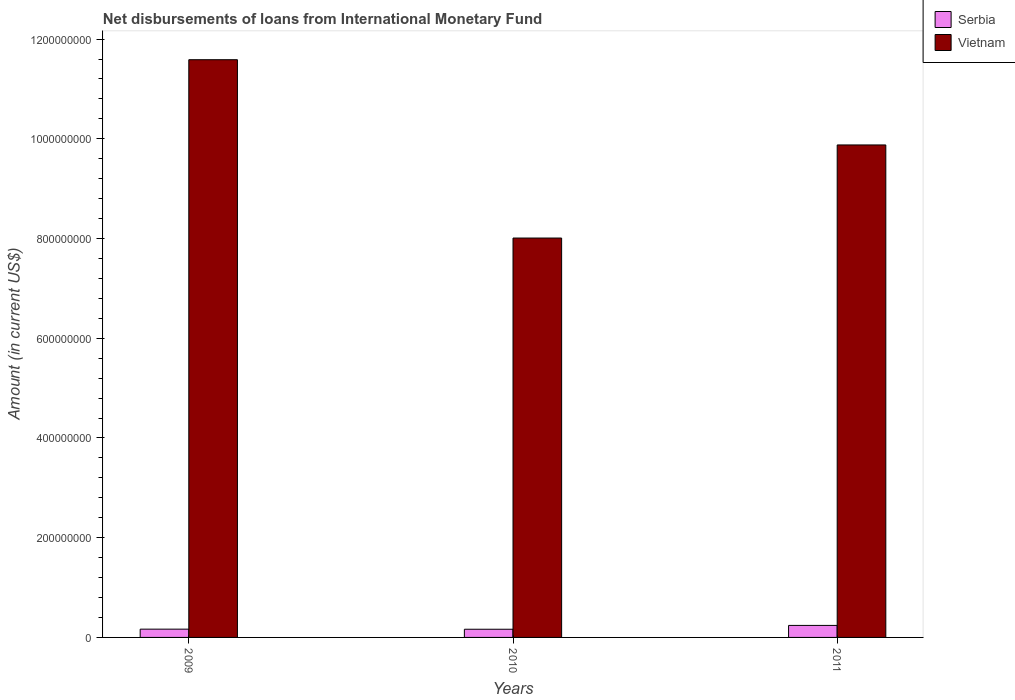How many different coloured bars are there?
Your response must be concise. 2. How many groups of bars are there?
Your response must be concise. 3. Are the number of bars on each tick of the X-axis equal?
Provide a short and direct response. Yes. What is the label of the 2nd group of bars from the left?
Make the answer very short. 2010. In how many cases, is the number of bars for a given year not equal to the number of legend labels?
Give a very brief answer. 0. What is the amount of loans disbursed in Vietnam in 2010?
Your answer should be compact. 8.01e+08. Across all years, what is the maximum amount of loans disbursed in Serbia?
Keep it short and to the point. 2.41e+07. Across all years, what is the minimum amount of loans disbursed in Vietnam?
Keep it short and to the point. 8.01e+08. What is the total amount of loans disbursed in Vietnam in the graph?
Offer a terse response. 2.95e+09. What is the difference between the amount of loans disbursed in Vietnam in 2009 and that in 2011?
Give a very brief answer. 1.71e+08. What is the difference between the amount of loans disbursed in Vietnam in 2011 and the amount of loans disbursed in Serbia in 2009?
Offer a terse response. 9.71e+08. What is the average amount of loans disbursed in Vietnam per year?
Your response must be concise. 9.82e+08. In the year 2009, what is the difference between the amount of loans disbursed in Serbia and amount of loans disbursed in Vietnam?
Your answer should be very brief. -1.14e+09. In how many years, is the amount of loans disbursed in Serbia greater than 1080000000 US$?
Make the answer very short. 0. What is the ratio of the amount of loans disbursed in Vietnam in 2009 to that in 2010?
Give a very brief answer. 1.45. What is the difference between the highest and the second highest amount of loans disbursed in Serbia?
Your answer should be compact. 7.47e+06. What is the difference between the highest and the lowest amount of loans disbursed in Vietnam?
Keep it short and to the point. 3.58e+08. Is the sum of the amount of loans disbursed in Vietnam in 2009 and 2011 greater than the maximum amount of loans disbursed in Serbia across all years?
Keep it short and to the point. Yes. What does the 1st bar from the left in 2011 represents?
Your response must be concise. Serbia. What does the 1st bar from the right in 2011 represents?
Give a very brief answer. Vietnam. Are all the bars in the graph horizontal?
Your answer should be very brief. No. How many years are there in the graph?
Offer a terse response. 3. What is the difference between two consecutive major ticks on the Y-axis?
Provide a short and direct response. 2.00e+08. Where does the legend appear in the graph?
Your response must be concise. Top right. How many legend labels are there?
Give a very brief answer. 2. How are the legend labels stacked?
Ensure brevity in your answer.  Vertical. What is the title of the graph?
Make the answer very short. Net disbursements of loans from International Monetary Fund. What is the Amount (in current US$) of Serbia in 2009?
Provide a succinct answer. 1.66e+07. What is the Amount (in current US$) of Vietnam in 2009?
Provide a short and direct response. 1.16e+09. What is the Amount (in current US$) in Serbia in 2010?
Your response must be concise. 1.64e+07. What is the Amount (in current US$) in Vietnam in 2010?
Make the answer very short. 8.01e+08. What is the Amount (in current US$) of Serbia in 2011?
Your response must be concise. 2.41e+07. What is the Amount (in current US$) in Vietnam in 2011?
Ensure brevity in your answer.  9.88e+08. Across all years, what is the maximum Amount (in current US$) of Serbia?
Make the answer very short. 2.41e+07. Across all years, what is the maximum Amount (in current US$) of Vietnam?
Ensure brevity in your answer.  1.16e+09. Across all years, what is the minimum Amount (in current US$) in Serbia?
Ensure brevity in your answer.  1.64e+07. Across all years, what is the minimum Amount (in current US$) in Vietnam?
Your answer should be compact. 8.01e+08. What is the total Amount (in current US$) of Serbia in the graph?
Your answer should be compact. 5.71e+07. What is the total Amount (in current US$) of Vietnam in the graph?
Your answer should be very brief. 2.95e+09. What is the difference between the Amount (in current US$) of Serbia in 2009 and that in 2010?
Provide a succinct answer. 2.02e+05. What is the difference between the Amount (in current US$) of Vietnam in 2009 and that in 2010?
Your answer should be compact. 3.58e+08. What is the difference between the Amount (in current US$) in Serbia in 2009 and that in 2011?
Your answer should be compact. -7.47e+06. What is the difference between the Amount (in current US$) of Vietnam in 2009 and that in 2011?
Your answer should be very brief. 1.71e+08. What is the difference between the Amount (in current US$) of Serbia in 2010 and that in 2011?
Give a very brief answer. -7.67e+06. What is the difference between the Amount (in current US$) of Vietnam in 2010 and that in 2011?
Offer a terse response. -1.87e+08. What is the difference between the Amount (in current US$) in Serbia in 2009 and the Amount (in current US$) in Vietnam in 2010?
Keep it short and to the point. -7.84e+08. What is the difference between the Amount (in current US$) of Serbia in 2009 and the Amount (in current US$) of Vietnam in 2011?
Offer a very short reply. -9.71e+08. What is the difference between the Amount (in current US$) in Serbia in 2010 and the Amount (in current US$) in Vietnam in 2011?
Your answer should be compact. -9.71e+08. What is the average Amount (in current US$) in Serbia per year?
Provide a short and direct response. 1.90e+07. What is the average Amount (in current US$) of Vietnam per year?
Provide a short and direct response. 9.82e+08. In the year 2009, what is the difference between the Amount (in current US$) in Serbia and Amount (in current US$) in Vietnam?
Your response must be concise. -1.14e+09. In the year 2010, what is the difference between the Amount (in current US$) in Serbia and Amount (in current US$) in Vietnam?
Offer a terse response. -7.85e+08. In the year 2011, what is the difference between the Amount (in current US$) in Serbia and Amount (in current US$) in Vietnam?
Provide a short and direct response. -9.64e+08. What is the ratio of the Amount (in current US$) of Serbia in 2009 to that in 2010?
Offer a terse response. 1.01. What is the ratio of the Amount (in current US$) in Vietnam in 2009 to that in 2010?
Make the answer very short. 1.45. What is the ratio of the Amount (in current US$) of Serbia in 2009 to that in 2011?
Offer a very short reply. 0.69. What is the ratio of the Amount (in current US$) in Vietnam in 2009 to that in 2011?
Your response must be concise. 1.17. What is the ratio of the Amount (in current US$) of Serbia in 2010 to that in 2011?
Keep it short and to the point. 0.68. What is the ratio of the Amount (in current US$) of Vietnam in 2010 to that in 2011?
Ensure brevity in your answer.  0.81. What is the difference between the highest and the second highest Amount (in current US$) in Serbia?
Offer a terse response. 7.47e+06. What is the difference between the highest and the second highest Amount (in current US$) in Vietnam?
Your response must be concise. 1.71e+08. What is the difference between the highest and the lowest Amount (in current US$) of Serbia?
Offer a very short reply. 7.67e+06. What is the difference between the highest and the lowest Amount (in current US$) of Vietnam?
Offer a very short reply. 3.58e+08. 